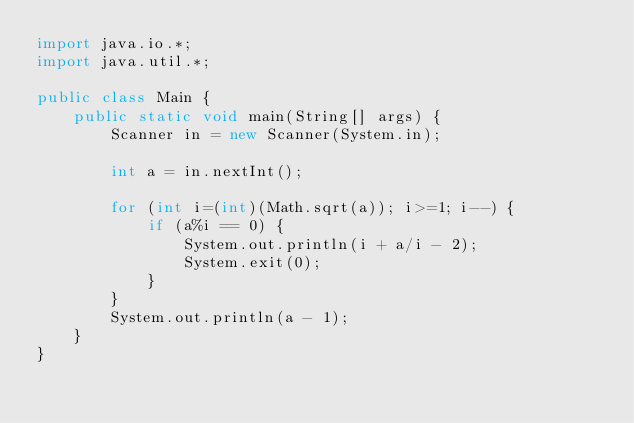Convert code to text. <code><loc_0><loc_0><loc_500><loc_500><_Java_>import java.io.*;
import java.util.*;

public class Main {
	public static void main(String[] args) {
		Scanner in = new Scanner(System.in);

		int a = in.nextInt();

		for (int i=(int)(Math.sqrt(a)); i>=1; i--) {
			if (a%i == 0) {
				System.out.println(i + a/i - 2);
				System.exit(0);
			}
		}
		System.out.println(a - 1);
	}
}

</code> 